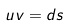Convert formula to latex. <formula><loc_0><loc_0><loc_500><loc_500>u v = d s</formula> 